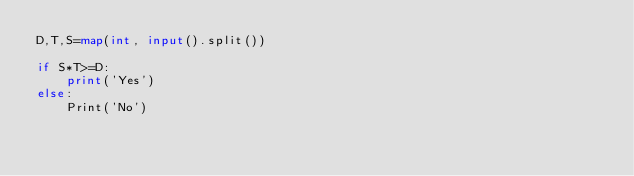<code> <loc_0><loc_0><loc_500><loc_500><_Python_>D,T,S=map(int, input().split())

if S*T>=D:
    print('Yes')
else:
    Print('No')</code> 